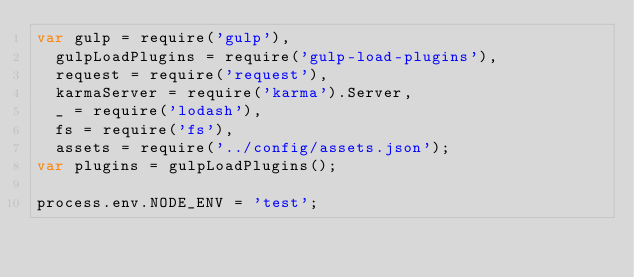<code> <loc_0><loc_0><loc_500><loc_500><_JavaScript_>var gulp = require('gulp'),
  gulpLoadPlugins = require('gulp-load-plugins'),
  request = require('request'),
  karmaServer = require('karma').Server,
  _ = require('lodash'),
  fs = require('fs'),
  assets = require('../config/assets.json');
var plugins = gulpLoadPlugins();

process.env.NODE_ENV = 'test';

</code> 